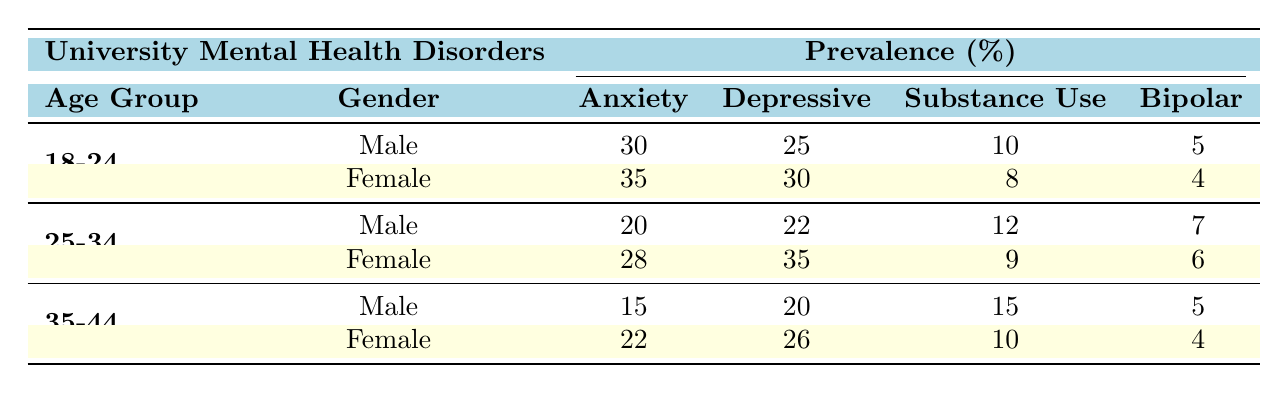What is the prevalence of anxiety disorders among females aged 18-24? From the table, the prevalence of anxiety disorders among females aged 18-24 is listed under the Female category in the 18-24 age group. It shows a prevalence of 35%.
Answer: 35% Which gender has a higher rate of depressive disorders in the 25-34 age group? In the 25-34 age group, the male rate for depressive disorders is 22%, while the female rate is 35%. Since 35% is greater than 22%, females have a higher rate.
Answer: Female What is the total percentage of substance use disorders for both genders combined in the 35-44 age group? To find the total percentage of substance use disorders for the 35-44 age group, we add the percentage for males (15%) and females (10%): 15 + 10 = 25%.
Answer: 25% Is it true that male students aged 25-34 have a higher prevalence of bipolar disorder than male students aged 18-24? The bipolar disorder prevalence among male students aged 25-34 is 7%, while for those aged 18-24, it is 5%. Since 7% is greater than 5%, the statement is true.
Answer: Yes What is the average prevalence of anxiety disorders across all age groups for females? The prevalence of anxiety disorders for females in each age group is: 35% (18-24), 28% (25-34), and 22% (35-44). To find the average, we sum these values: 35 + 28 + 22 = 85%, and divide by 3 (the number of age groups): 85 / 3 = 28.33%.
Answer: 28.33% 